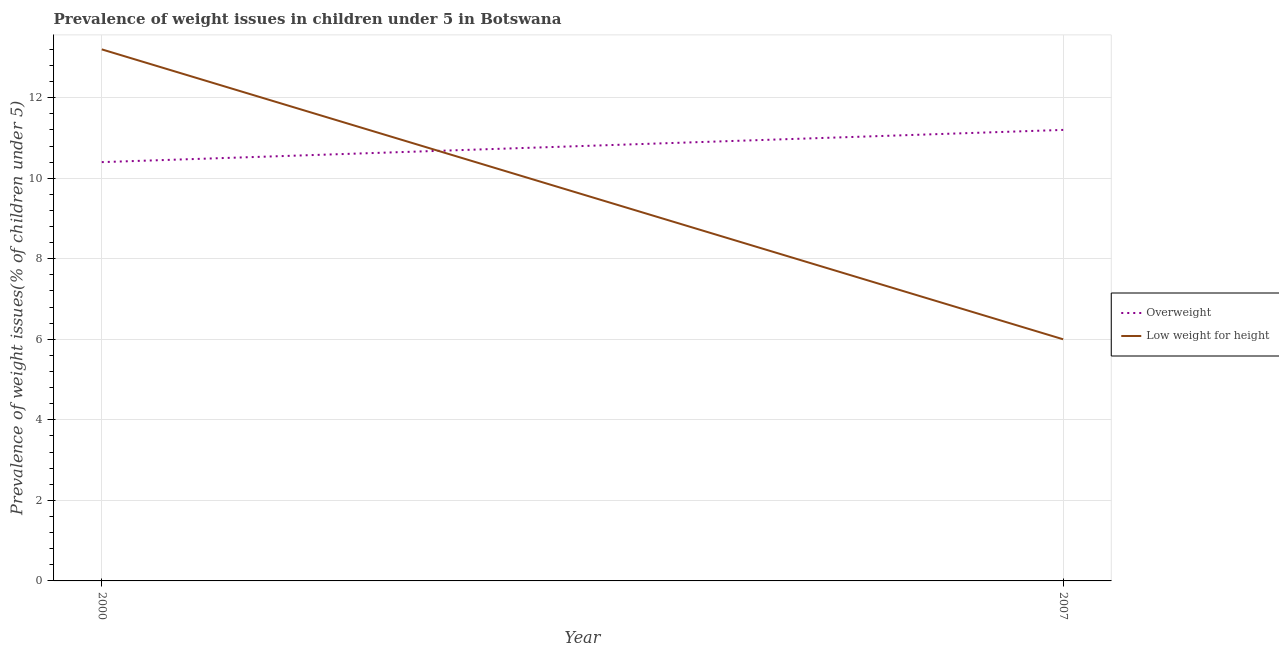Is the number of lines equal to the number of legend labels?
Give a very brief answer. Yes. Across all years, what is the maximum percentage of underweight children?
Provide a succinct answer. 13.2. In which year was the percentage of underweight children maximum?
Ensure brevity in your answer.  2000. In which year was the percentage of underweight children minimum?
Your answer should be very brief. 2007. What is the total percentage of overweight children in the graph?
Offer a terse response. 21.6. What is the difference between the percentage of overweight children in 2000 and that in 2007?
Make the answer very short. -0.8. What is the difference between the percentage of overweight children in 2007 and the percentage of underweight children in 2000?
Your response must be concise. -2. What is the average percentage of overweight children per year?
Your response must be concise. 10.8. In the year 2007, what is the difference between the percentage of overweight children and percentage of underweight children?
Provide a succinct answer. 5.2. In how many years, is the percentage of overweight children greater than 2.4 %?
Provide a succinct answer. 2. What is the ratio of the percentage of overweight children in 2000 to that in 2007?
Make the answer very short. 0.93. Is the percentage of underweight children in 2000 less than that in 2007?
Your response must be concise. No. Does the percentage of underweight children monotonically increase over the years?
Provide a short and direct response. No. Is the percentage of underweight children strictly greater than the percentage of overweight children over the years?
Your answer should be compact. No. How many lines are there?
Your answer should be compact. 2. How many years are there in the graph?
Provide a succinct answer. 2. What is the difference between two consecutive major ticks on the Y-axis?
Give a very brief answer. 2. Are the values on the major ticks of Y-axis written in scientific E-notation?
Ensure brevity in your answer.  No. Does the graph contain any zero values?
Make the answer very short. No. Does the graph contain grids?
Offer a terse response. Yes. Where does the legend appear in the graph?
Ensure brevity in your answer.  Center right. How many legend labels are there?
Make the answer very short. 2. How are the legend labels stacked?
Your answer should be compact. Vertical. What is the title of the graph?
Ensure brevity in your answer.  Prevalence of weight issues in children under 5 in Botswana. Does "Registered firms" appear as one of the legend labels in the graph?
Provide a succinct answer. No. What is the label or title of the Y-axis?
Keep it short and to the point. Prevalence of weight issues(% of children under 5). What is the Prevalence of weight issues(% of children under 5) of Overweight in 2000?
Make the answer very short. 10.4. What is the Prevalence of weight issues(% of children under 5) of Low weight for height in 2000?
Make the answer very short. 13.2. What is the Prevalence of weight issues(% of children under 5) in Overweight in 2007?
Your response must be concise. 11.2. What is the Prevalence of weight issues(% of children under 5) of Low weight for height in 2007?
Your answer should be very brief. 6. Across all years, what is the maximum Prevalence of weight issues(% of children under 5) of Overweight?
Provide a short and direct response. 11.2. Across all years, what is the maximum Prevalence of weight issues(% of children under 5) in Low weight for height?
Your answer should be very brief. 13.2. Across all years, what is the minimum Prevalence of weight issues(% of children under 5) of Overweight?
Make the answer very short. 10.4. Across all years, what is the minimum Prevalence of weight issues(% of children under 5) of Low weight for height?
Keep it short and to the point. 6. What is the total Prevalence of weight issues(% of children under 5) in Overweight in the graph?
Ensure brevity in your answer.  21.6. What is the total Prevalence of weight issues(% of children under 5) in Low weight for height in the graph?
Your answer should be compact. 19.2. What is the average Prevalence of weight issues(% of children under 5) of Overweight per year?
Your response must be concise. 10.8. In the year 2000, what is the difference between the Prevalence of weight issues(% of children under 5) of Overweight and Prevalence of weight issues(% of children under 5) of Low weight for height?
Make the answer very short. -2.8. In the year 2007, what is the difference between the Prevalence of weight issues(% of children under 5) in Overweight and Prevalence of weight issues(% of children under 5) in Low weight for height?
Offer a terse response. 5.2. What is the ratio of the Prevalence of weight issues(% of children under 5) of Low weight for height in 2000 to that in 2007?
Keep it short and to the point. 2.2. What is the difference between the highest and the second highest Prevalence of weight issues(% of children under 5) of Low weight for height?
Provide a short and direct response. 7.2. What is the difference between the highest and the lowest Prevalence of weight issues(% of children under 5) in Overweight?
Offer a very short reply. 0.8. 